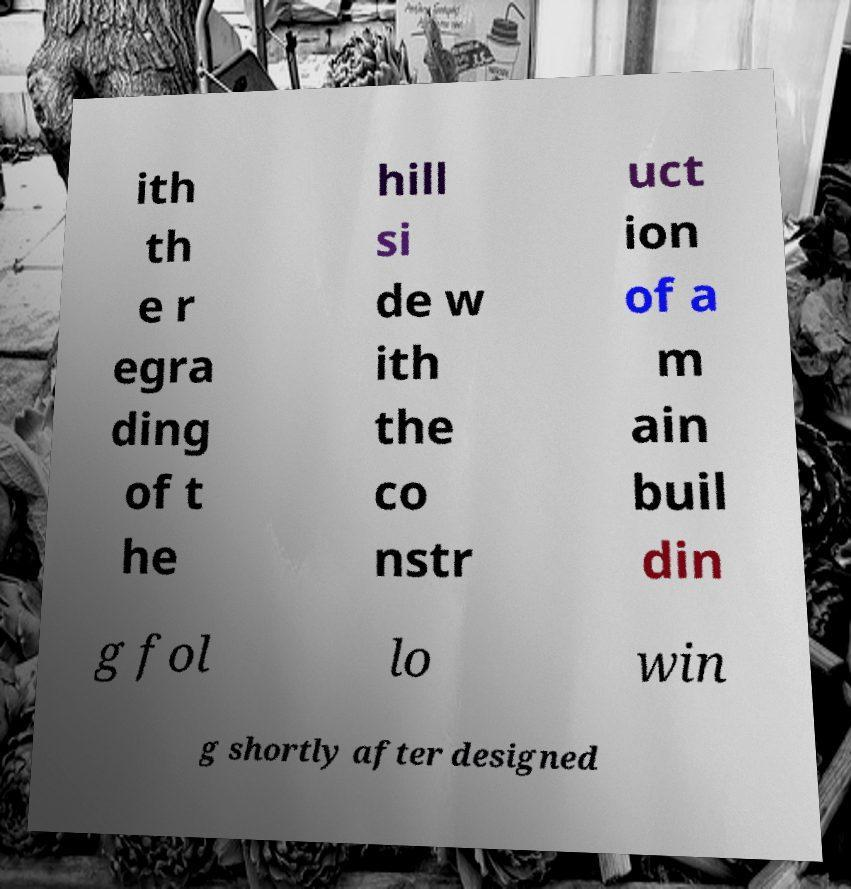What messages or text are displayed in this image? I need them in a readable, typed format. ith th e r egra ding of t he hill si de w ith the co nstr uct ion of a m ain buil din g fol lo win g shortly after designed 